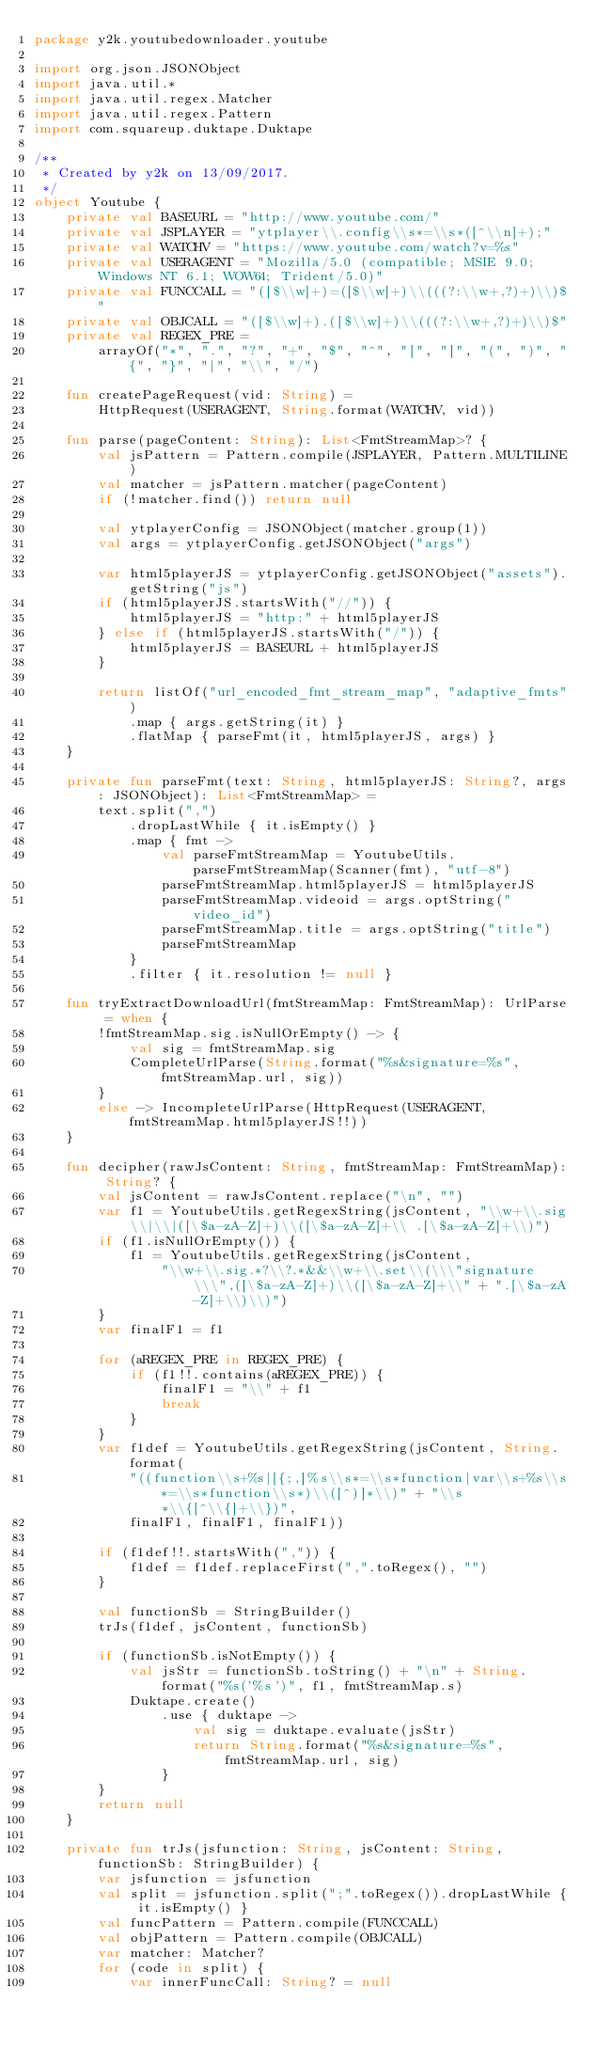Convert code to text. <code><loc_0><loc_0><loc_500><loc_500><_Kotlin_>package y2k.youtubedownloader.youtube

import org.json.JSONObject
import java.util.*
import java.util.regex.Matcher
import java.util.regex.Pattern
import com.squareup.duktape.Duktape

/**
 * Created by y2k on 13/09/2017.
 */
object Youtube {
    private val BASEURL = "http://www.youtube.com/"
    private val JSPLAYER = "ytplayer\\.config\\s*=\\s*([^\\n]+);"
    private val WATCHV = "https://www.youtube.com/watch?v=%s"
    private val USERAGENT = "Mozilla/5.0 (compatible; MSIE 9.0; Windows NT 6.1; WOW64; Trident/5.0)"
    private val FUNCCALL = "([$\\w]+)=([$\\w]+)\\(((?:\\w+,?)+)\\)$"
    private val OBJCALL = "([$\\w]+).([$\\w]+)\\(((?:\\w+,?)+)\\)$"
    private val REGEX_PRE =
        arrayOf("*", ".", "?", "+", "$", "^", "[", "]", "(", ")", "{", "}", "|", "\\", "/")

    fun createPageRequest(vid: String) =
        HttpRequest(USERAGENT, String.format(WATCHV, vid))

    fun parse(pageContent: String): List<FmtStreamMap>? {
        val jsPattern = Pattern.compile(JSPLAYER, Pattern.MULTILINE)
        val matcher = jsPattern.matcher(pageContent)
        if (!matcher.find()) return null

        val ytplayerConfig = JSONObject(matcher.group(1))
        val args = ytplayerConfig.getJSONObject("args")

        var html5playerJS = ytplayerConfig.getJSONObject("assets").getString("js")
        if (html5playerJS.startsWith("//")) {
            html5playerJS = "http:" + html5playerJS
        } else if (html5playerJS.startsWith("/")) {
            html5playerJS = BASEURL + html5playerJS
        }

        return listOf("url_encoded_fmt_stream_map", "adaptive_fmts")
            .map { args.getString(it) }
            .flatMap { parseFmt(it, html5playerJS, args) }
    }

    private fun parseFmt(text: String, html5playerJS: String?, args: JSONObject): List<FmtStreamMap> =
        text.split(",")
            .dropLastWhile { it.isEmpty() }
            .map { fmt ->
                val parseFmtStreamMap = YoutubeUtils.parseFmtStreamMap(Scanner(fmt), "utf-8")
                parseFmtStreamMap.html5playerJS = html5playerJS
                parseFmtStreamMap.videoid = args.optString("video_id")
                parseFmtStreamMap.title = args.optString("title")
                parseFmtStreamMap
            }
            .filter { it.resolution != null }

    fun tryExtractDownloadUrl(fmtStreamMap: FmtStreamMap): UrlParse = when {
        !fmtStreamMap.sig.isNullOrEmpty() -> {
            val sig = fmtStreamMap.sig
            CompleteUrlParse(String.format("%s&signature=%s", fmtStreamMap.url, sig))
        }
        else -> IncompleteUrlParse(HttpRequest(USERAGENT, fmtStreamMap.html5playerJS!!))
    }

    fun decipher(rawJsContent: String, fmtStreamMap: FmtStreamMap): String? {
        val jsContent = rawJsContent.replace("\n", "")
        var f1 = YoutubeUtils.getRegexString(jsContent, "\\w+\\.sig\\|\\|([\$a-zA-Z]+)\\([\$a-zA-Z]+\\ .[\$a-zA-Z]+\\)")
        if (f1.isNullOrEmpty()) {
            f1 = YoutubeUtils.getRegexString(jsContent,
                "\\w+\\.sig.*?\\?.*&&\\w+\\.set\\(\\\"signature\\\",([\$a-zA-Z]+)\\([\$a-zA-Z]+\\" + ".[\$a-zA-Z]+\\)\\)")
        }
        var finalF1 = f1

        for (aREGEX_PRE in REGEX_PRE) {
            if (f1!!.contains(aREGEX_PRE)) {
                finalF1 = "\\" + f1
                break
            }
        }
        var f1def = YoutubeUtils.getRegexString(jsContent, String.format(
            "((function\\s+%s|[{;,]%s\\s*=\\s*function|var\\s+%s\\s*=\\s*function\\s*)\\([^)]*\\)" + "\\s*\\{[^\\{]+\\})",
            finalF1, finalF1, finalF1))

        if (f1def!!.startsWith(",")) {
            f1def = f1def.replaceFirst(",".toRegex(), "")
        }

        val functionSb = StringBuilder()
        trJs(f1def, jsContent, functionSb)

        if (functionSb.isNotEmpty()) {
            val jsStr = functionSb.toString() + "\n" + String.format("%s('%s')", f1, fmtStreamMap.s)
            Duktape.create()
                .use { duktape ->
                    val sig = duktape.evaluate(jsStr)
                    return String.format("%s&signature=%s", fmtStreamMap.url, sig)
                }
        }
        return null
    }

    private fun trJs(jsfunction: String, jsContent: String, functionSb: StringBuilder) {
        var jsfunction = jsfunction
        val split = jsfunction.split(";".toRegex()).dropLastWhile { it.isEmpty() }
        val funcPattern = Pattern.compile(FUNCCALL)
        val objPattern = Pattern.compile(OBJCALL)
        var matcher: Matcher?
        for (code in split) {
            var innerFuncCall: String? = null</code> 